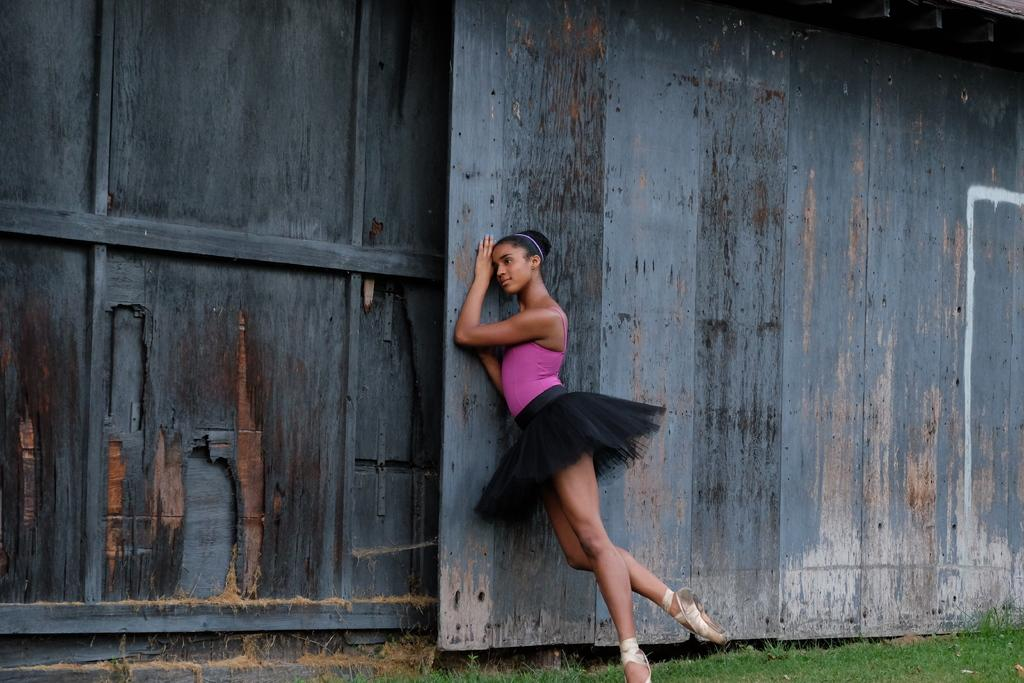What is the main subject of the image? There is a person standing in the image. What type of material is used for the walls in the image? There are wooden walls in the image. What type of vegetation can be seen in the image? There is grass visible in the image. What color is the wool on the person's tooth in the image? There is no wool or tooth present on the person in the image. 